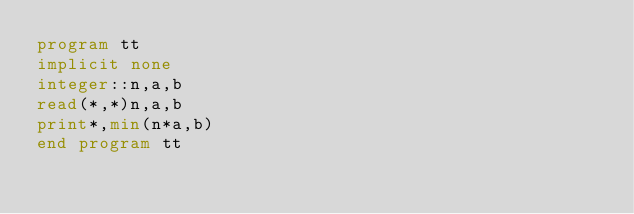<code> <loc_0><loc_0><loc_500><loc_500><_FORTRAN_>program tt
implicit none
integer::n,a,b
read(*,*)n,a,b
print*,min(n*a,b)
end program tt</code> 